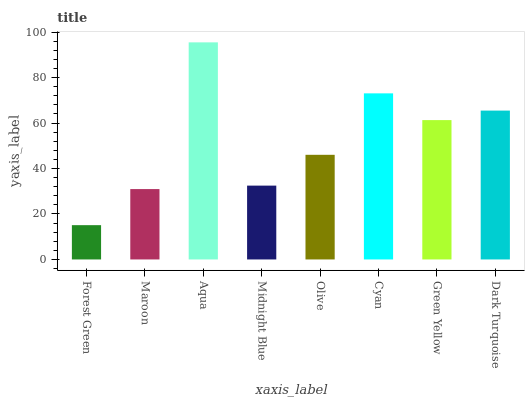Is Forest Green the minimum?
Answer yes or no. Yes. Is Aqua the maximum?
Answer yes or no. Yes. Is Maroon the minimum?
Answer yes or no. No. Is Maroon the maximum?
Answer yes or no. No. Is Maroon greater than Forest Green?
Answer yes or no. Yes. Is Forest Green less than Maroon?
Answer yes or no. Yes. Is Forest Green greater than Maroon?
Answer yes or no. No. Is Maroon less than Forest Green?
Answer yes or no. No. Is Green Yellow the high median?
Answer yes or no. Yes. Is Olive the low median?
Answer yes or no. Yes. Is Aqua the high median?
Answer yes or no. No. Is Dark Turquoise the low median?
Answer yes or no. No. 